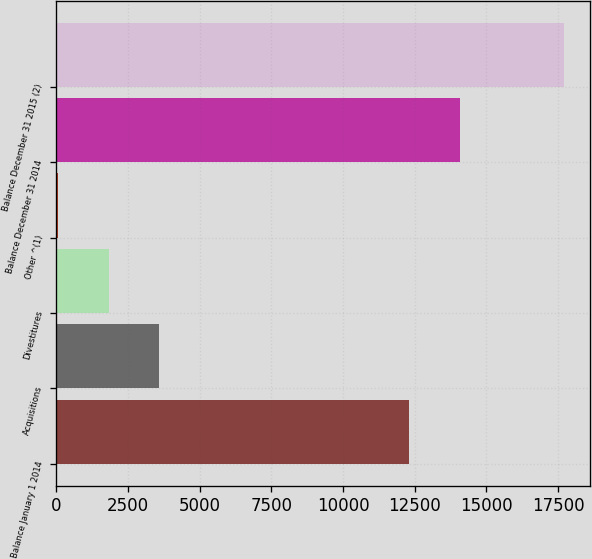<chart> <loc_0><loc_0><loc_500><loc_500><bar_chart><fcel>Balance January 1 2014<fcel>Acquisitions<fcel>Divestitures<fcel>Other ^(1)<fcel>Balance December 31 2014<fcel>Balance December 31 2015 (2)<nl><fcel>12301<fcel>3593.4<fcel>1827.2<fcel>61<fcel>14067.2<fcel>17723<nl></chart> 